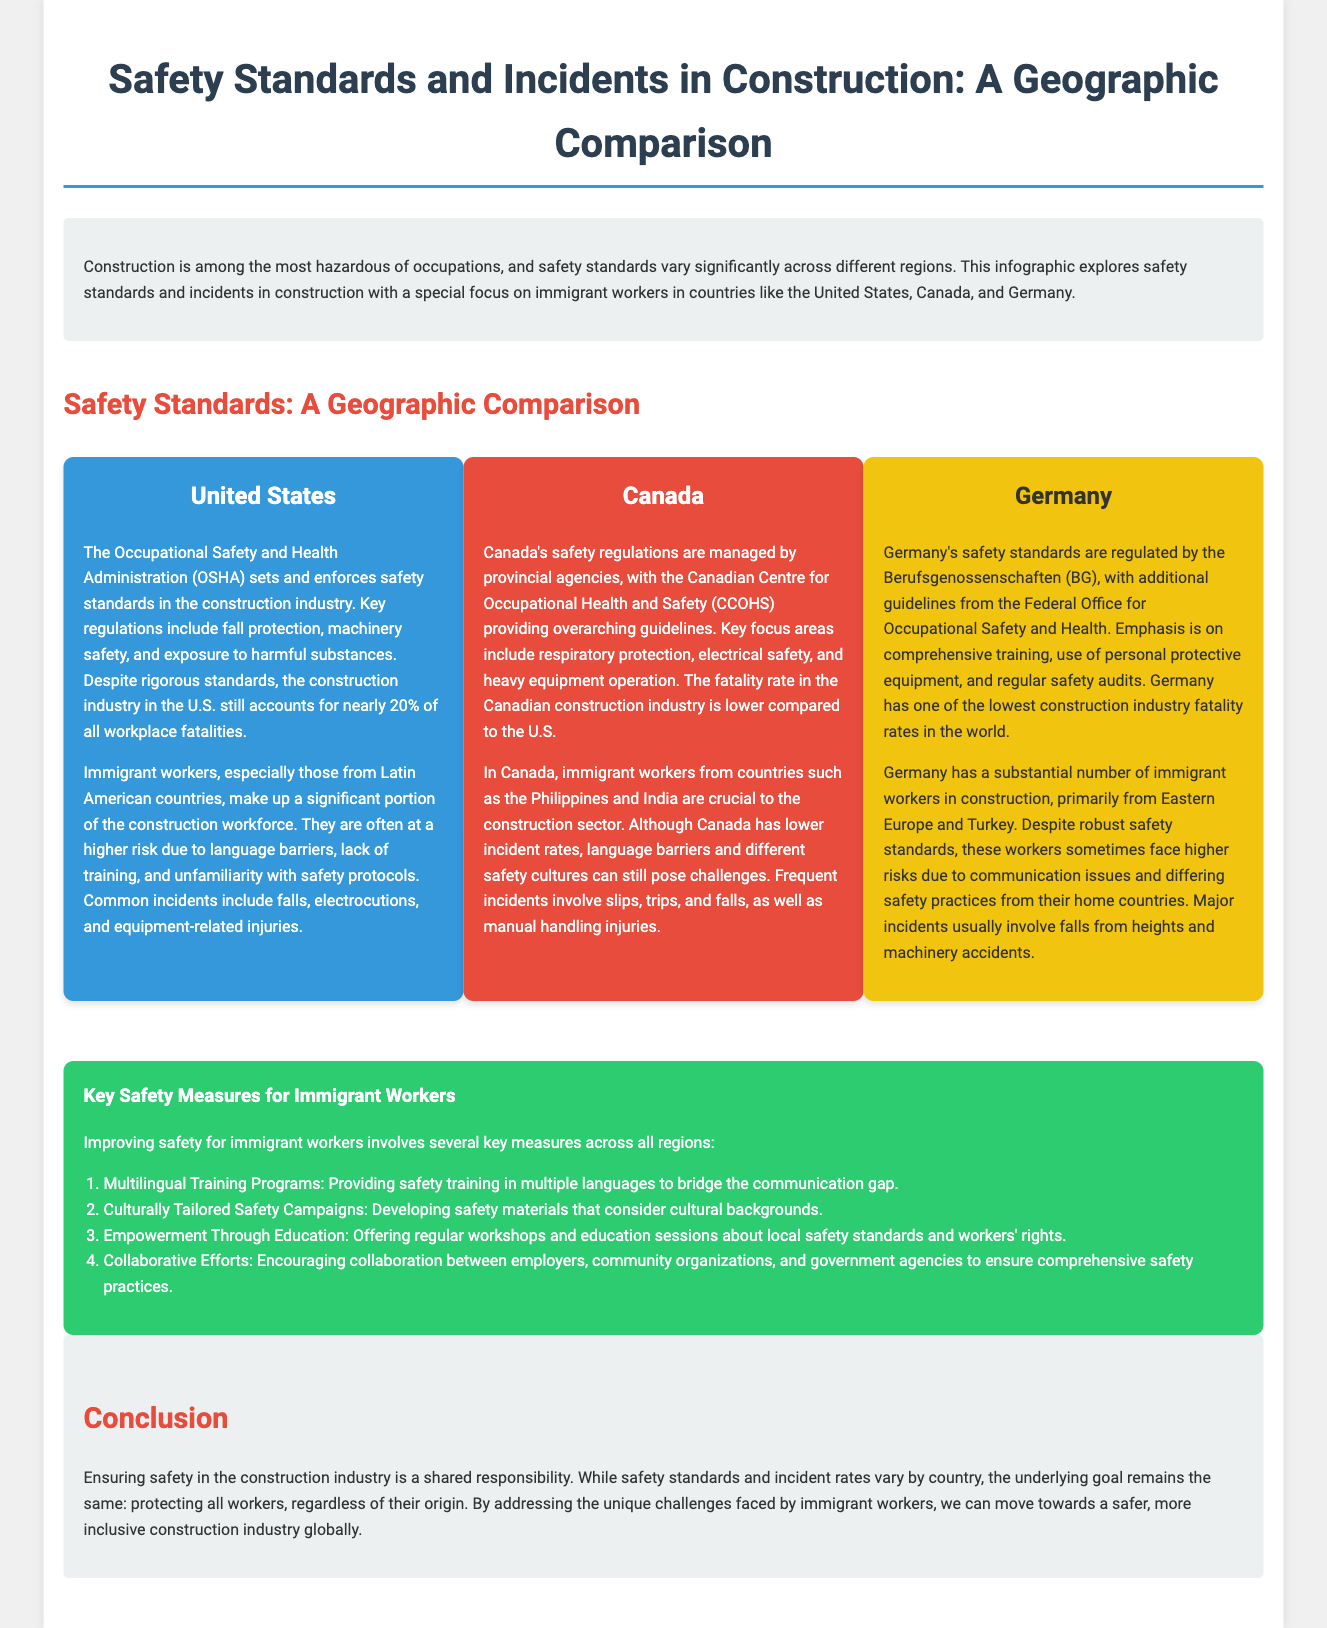what agency sets safety standards in the United States construction industry? The agency mentioned that sets and enforces safety standards in the U.S. construction industry is the Occupational Safety and Health Administration.
Answer: Occupational Safety and Health Administration which country has the lowest construction industry fatality rates? The document states that Germany has one of the lowest construction industry fatality rates in the world.
Answer: Germany what issues do immigrant workers from Latin America face in the U.S.? The document notes that immigrant workers in the U.S. often face higher risks due to language barriers, lack of training, and unfamiliarity with safety protocols.
Answer: Language barriers, lack of training, and unfamiliarity with safety protocols what type of incidents are most common for immigrant workers in Canada? Frequent incidents mentioned in Canada for immigrant workers involve slips, trips, and falls, as well as manual handling injuries.
Answer: Slips, trips, and falls; manual handling injuries what key measure focuses on communication for immigrant workers' safety? The key safety measure aimed at improving communication is providing safety training in multiple languages.
Answer: Multilingual Training Programs how do safety regulations differ in Canada compared to the United States? In Canada, safety regulations are managed by provincial agencies, unlike in the U.S. where the OSHA sets safety standards.
Answer: Managed by provincial agencies which immigrant worker populations are significant in Canada? The document highlights that immigrant workers from countries such as the Philippines and India are crucial to the construction sector in Canada.
Answer: Philippines and India what are the guidelines provided by the Federal Office for Occupational Safety and Health in Germany? The guidelines emphasize comprehensive training, use of personal protective equipment, and regular safety audits.
Answer: Comprehensive training, use of personal protective equipment, and regular safety audits what is the overarching goal mentioned in the conclusion regarding worker safety? The conclusion states that the underlying goal is to protect all workers, regardless of their origin.
Answer: Protecting all workers, regardless of their origin 